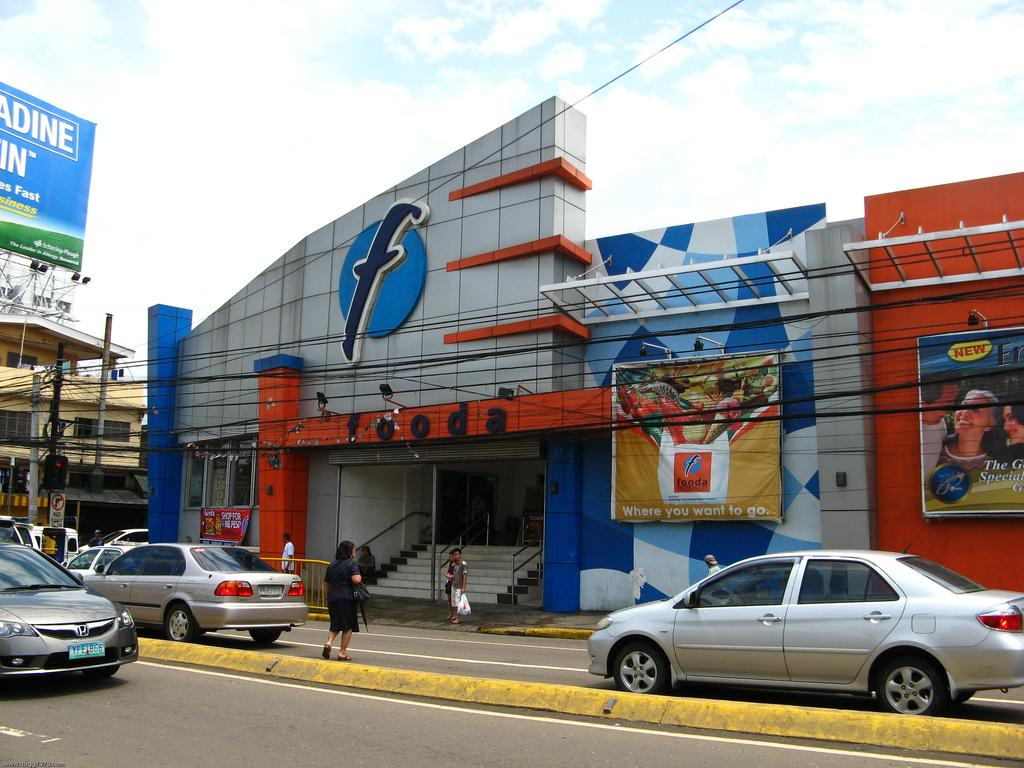<image>
Provide a brief description of the given image. A store called "fooda" has a huge letter F on the front of it. 